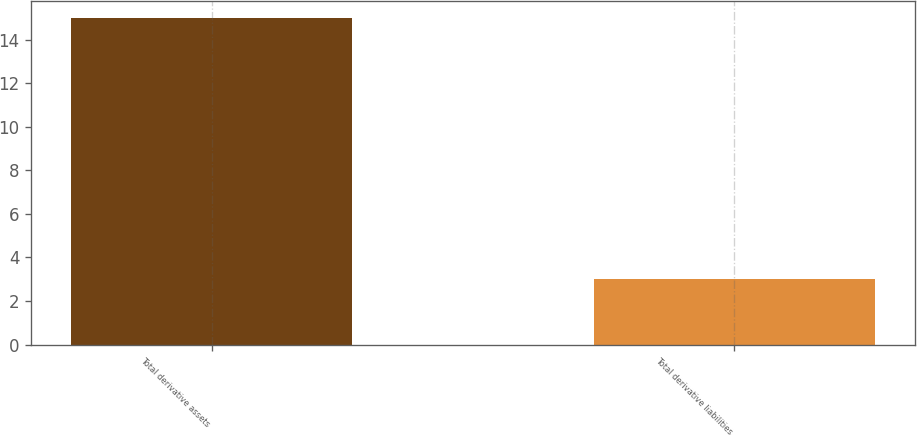Convert chart to OTSL. <chart><loc_0><loc_0><loc_500><loc_500><bar_chart><fcel>Total derivative assets<fcel>Total derivative liabilities<nl><fcel>15<fcel>3<nl></chart> 